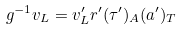<formula> <loc_0><loc_0><loc_500><loc_500>g ^ { - 1 } { v } _ { L } = { v } ^ { \prime } _ { L } r ^ { \prime } ( \tau ^ { \prime } ) _ { A } ( { a } ^ { \prime } ) _ { T }</formula> 